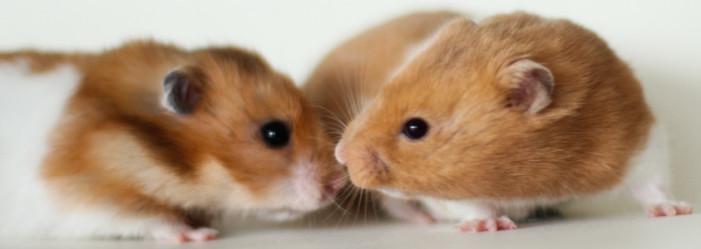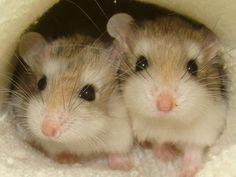The first image is the image on the left, the second image is the image on the right. Assess this claim about the two images: "The rodents in the image on the left are face to face.". Correct or not? Answer yes or no. Yes. The first image is the image on the left, the second image is the image on the right. Evaluate the accuracy of this statement regarding the images: "Each image contains two pet rodents, and at least one image includes a rodent sitting upright.". Is it true? Answer yes or no. No. 